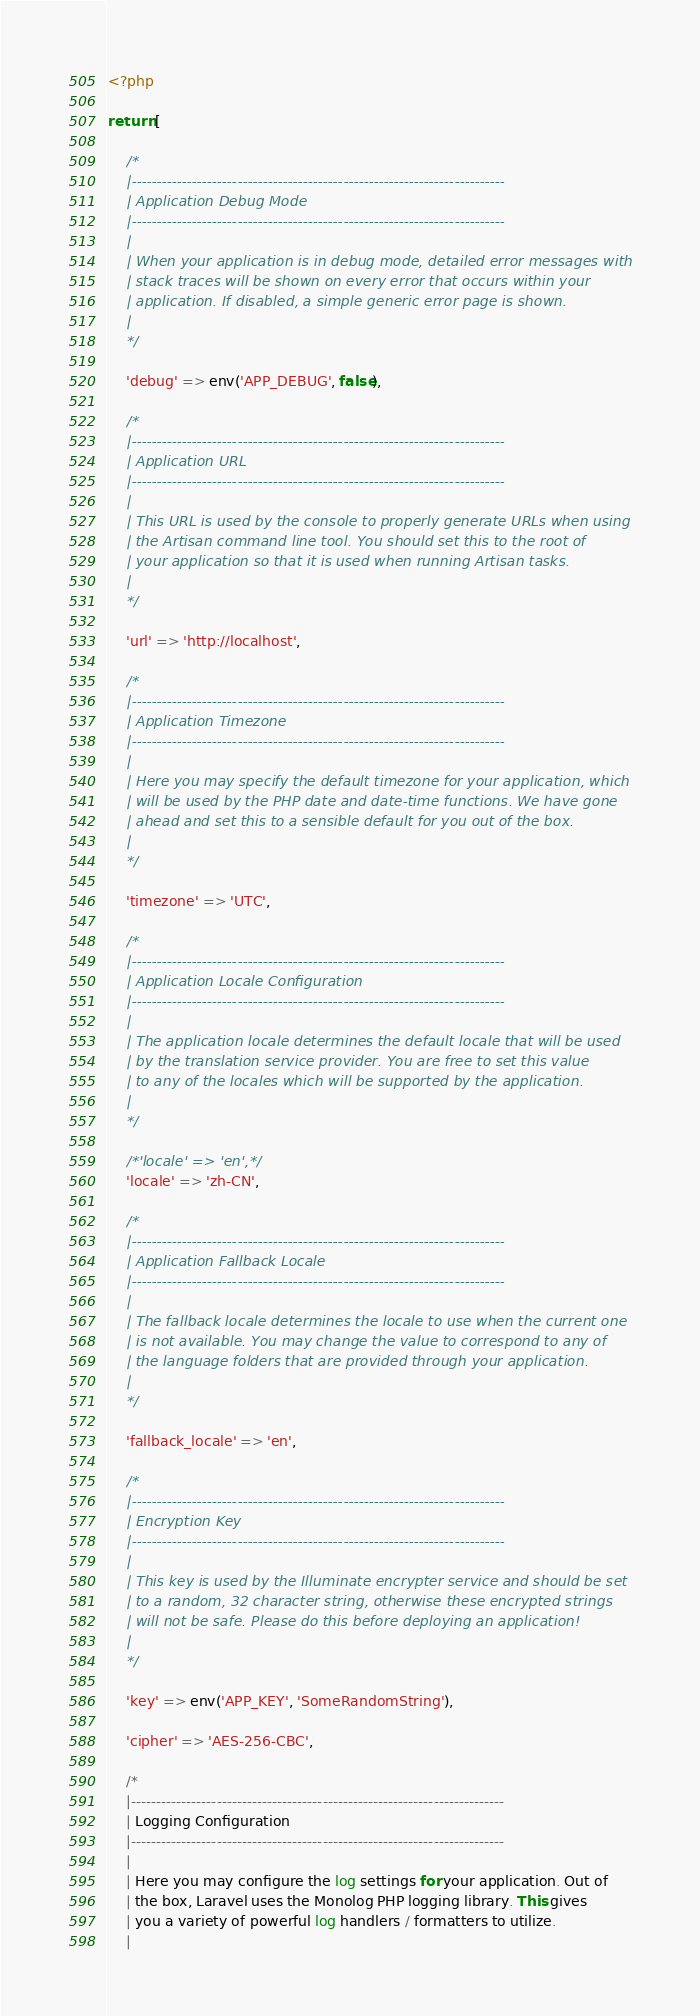Convert code to text. <code><loc_0><loc_0><loc_500><loc_500><_PHP_><?php

return [

    /*
    |--------------------------------------------------------------------------
    | Application Debug Mode
    |--------------------------------------------------------------------------
    |
    | When your application is in debug mode, detailed error messages with
    | stack traces will be shown on every error that occurs within your
    | application. If disabled, a simple generic error page is shown.
    |
    */

    'debug' => env('APP_DEBUG', false),

    /*
    |--------------------------------------------------------------------------
    | Application URL
    |--------------------------------------------------------------------------
    |
    | This URL is used by the console to properly generate URLs when using
    | the Artisan command line tool. You should set this to the root of
    | your application so that it is used when running Artisan tasks.
    |
    */

    'url' => 'http://localhost',

    /*
    |--------------------------------------------------------------------------
    | Application Timezone
    |--------------------------------------------------------------------------
    |
    | Here you may specify the default timezone for your application, which
    | will be used by the PHP date and date-time functions. We have gone
    | ahead and set this to a sensible default for you out of the box.
    |
    */

    'timezone' => 'UTC',

    /*
    |--------------------------------------------------------------------------
    | Application Locale Configuration
    |--------------------------------------------------------------------------
    |
    | The application locale determines the default locale that will be used
    | by the translation service provider. You are free to set this value
    | to any of the locales which will be supported by the application.
    |
    */

    /*'locale' => 'en',*/
    'locale' => 'zh-CN',

    /*
    |--------------------------------------------------------------------------
    | Application Fallback Locale
    |--------------------------------------------------------------------------
    |
    | The fallback locale determines the locale to use when the current one
    | is not available. You may change the value to correspond to any of
    | the language folders that are provided through your application.
    |
    */

    'fallback_locale' => 'en',

    /*
    |--------------------------------------------------------------------------
    | Encryption Key
    |--------------------------------------------------------------------------
    |
    | This key is used by the Illuminate encrypter service and should be set
    | to a random, 32 character string, otherwise these encrypted strings
    | will not be safe. Please do this before deploying an application!
    |
    */

    'key' => env('APP_KEY', 'SomeRandomString'),

    'cipher' => 'AES-256-CBC',

    /*
    |--------------------------------------------------------------------------
    | Logging Configuration
    |--------------------------------------------------------------------------
    |
    | Here you may configure the log settings for your application. Out of
    | the box, Laravel uses the Monolog PHP logging library. This gives
    | you a variety of powerful log handlers / formatters to utilize.
    |</code> 